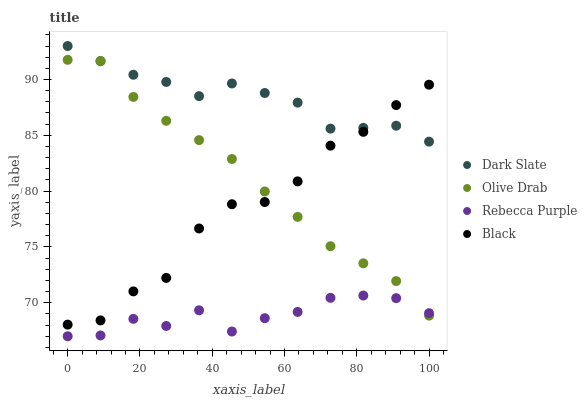Does Rebecca Purple have the minimum area under the curve?
Answer yes or no. Yes. Does Dark Slate have the maximum area under the curve?
Answer yes or no. Yes. Does Black have the minimum area under the curve?
Answer yes or no. No. Does Black have the maximum area under the curve?
Answer yes or no. No. Is Olive Drab the smoothest?
Answer yes or no. Yes. Is Black the roughest?
Answer yes or no. Yes. Is Rebecca Purple the smoothest?
Answer yes or no. No. Is Rebecca Purple the roughest?
Answer yes or no. No. Does Rebecca Purple have the lowest value?
Answer yes or no. Yes. Does Black have the lowest value?
Answer yes or no. No. Does Dark Slate have the highest value?
Answer yes or no. Yes. Does Black have the highest value?
Answer yes or no. No. Is Rebecca Purple less than Dark Slate?
Answer yes or no. Yes. Is Dark Slate greater than Rebecca Purple?
Answer yes or no. Yes. Does Olive Drab intersect Black?
Answer yes or no. Yes. Is Olive Drab less than Black?
Answer yes or no. No. Is Olive Drab greater than Black?
Answer yes or no. No. Does Rebecca Purple intersect Dark Slate?
Answer yes or no. No. 